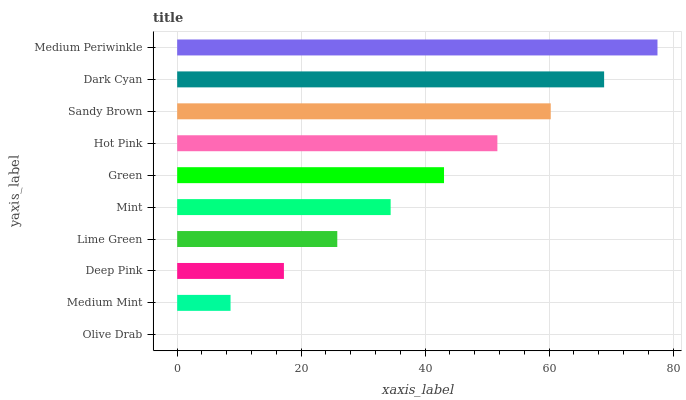Is Olive Drab the minimum?
Answer yes or no. Yes. Is Medium Periwinkle the maximum?
Answer yes or no. Yes. Is Medium Mint the minimum?
Answer yes or no. No. Is Medium Mint the maximum?
Answer yes or no. No. Is Medium Mint greater than Olive Drab?
Answer yes or no. Yes. Is Olive Drab less than Medium Mint?
Answer yes or no. Yes. Is Olive Drab greater than Medium Mint?
Answer yes or no. No. Is Medium Mint less than Olive Drab?
Answer yes or no. No. Is Green the high median?
Answer yes or no. Yes. Is Mint the low median?
Answer yes or no. Yes. Is Medium Mint the high median?
Answer yes or no. No. Is Hot Pink the low median?
Answer yes or no. No. 